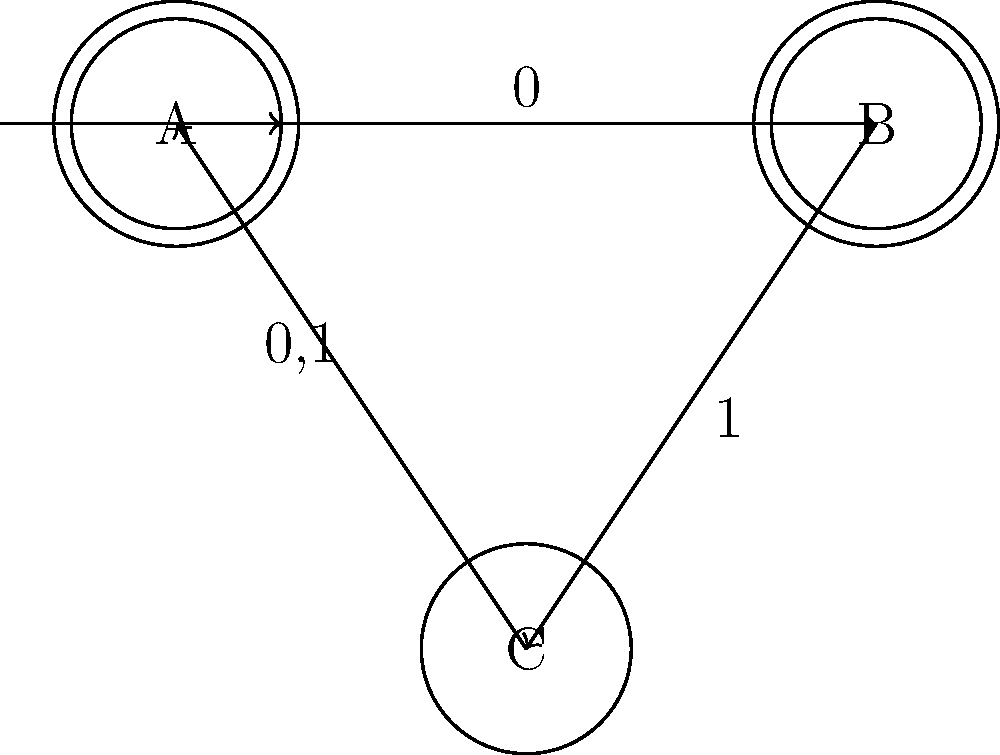Design a finite state machine (FSM) that accepts strings over the alphabet $\{0,1\}$ that contain an even number of 0s and end with a 1. Based on the given FSM diagram, what is the shortest string accepted by this machine? Let's analyze the FSM step-by-step:

1. State A is both the initial and a final state. It represents having seen an even number of 0s.
2. State B is also a final state. It represents having seen an odd number of 0s and ending with a 1.
3. State C represents having seen an odd number of 0s.

To find the shortest accepted string:

1. We need to end in either state A or B (final states).
2. The string must end with a 1 (requirement in the question).
3. The shortest path to a final state ending with 1 is:
   A (start) -> B (via 0) -> B (via 1)

This path corresponds to the string "01".

Let's verify:
- Start at A (even 0s)
- Read 0: Move to B (odd 0s)
- Read 1: Stay in B (odd 0s, ends with 1)

The string "01" contains an even number of 0s (zero is even) and ends with a 1, satisfying both conditions.
Answer: 01 